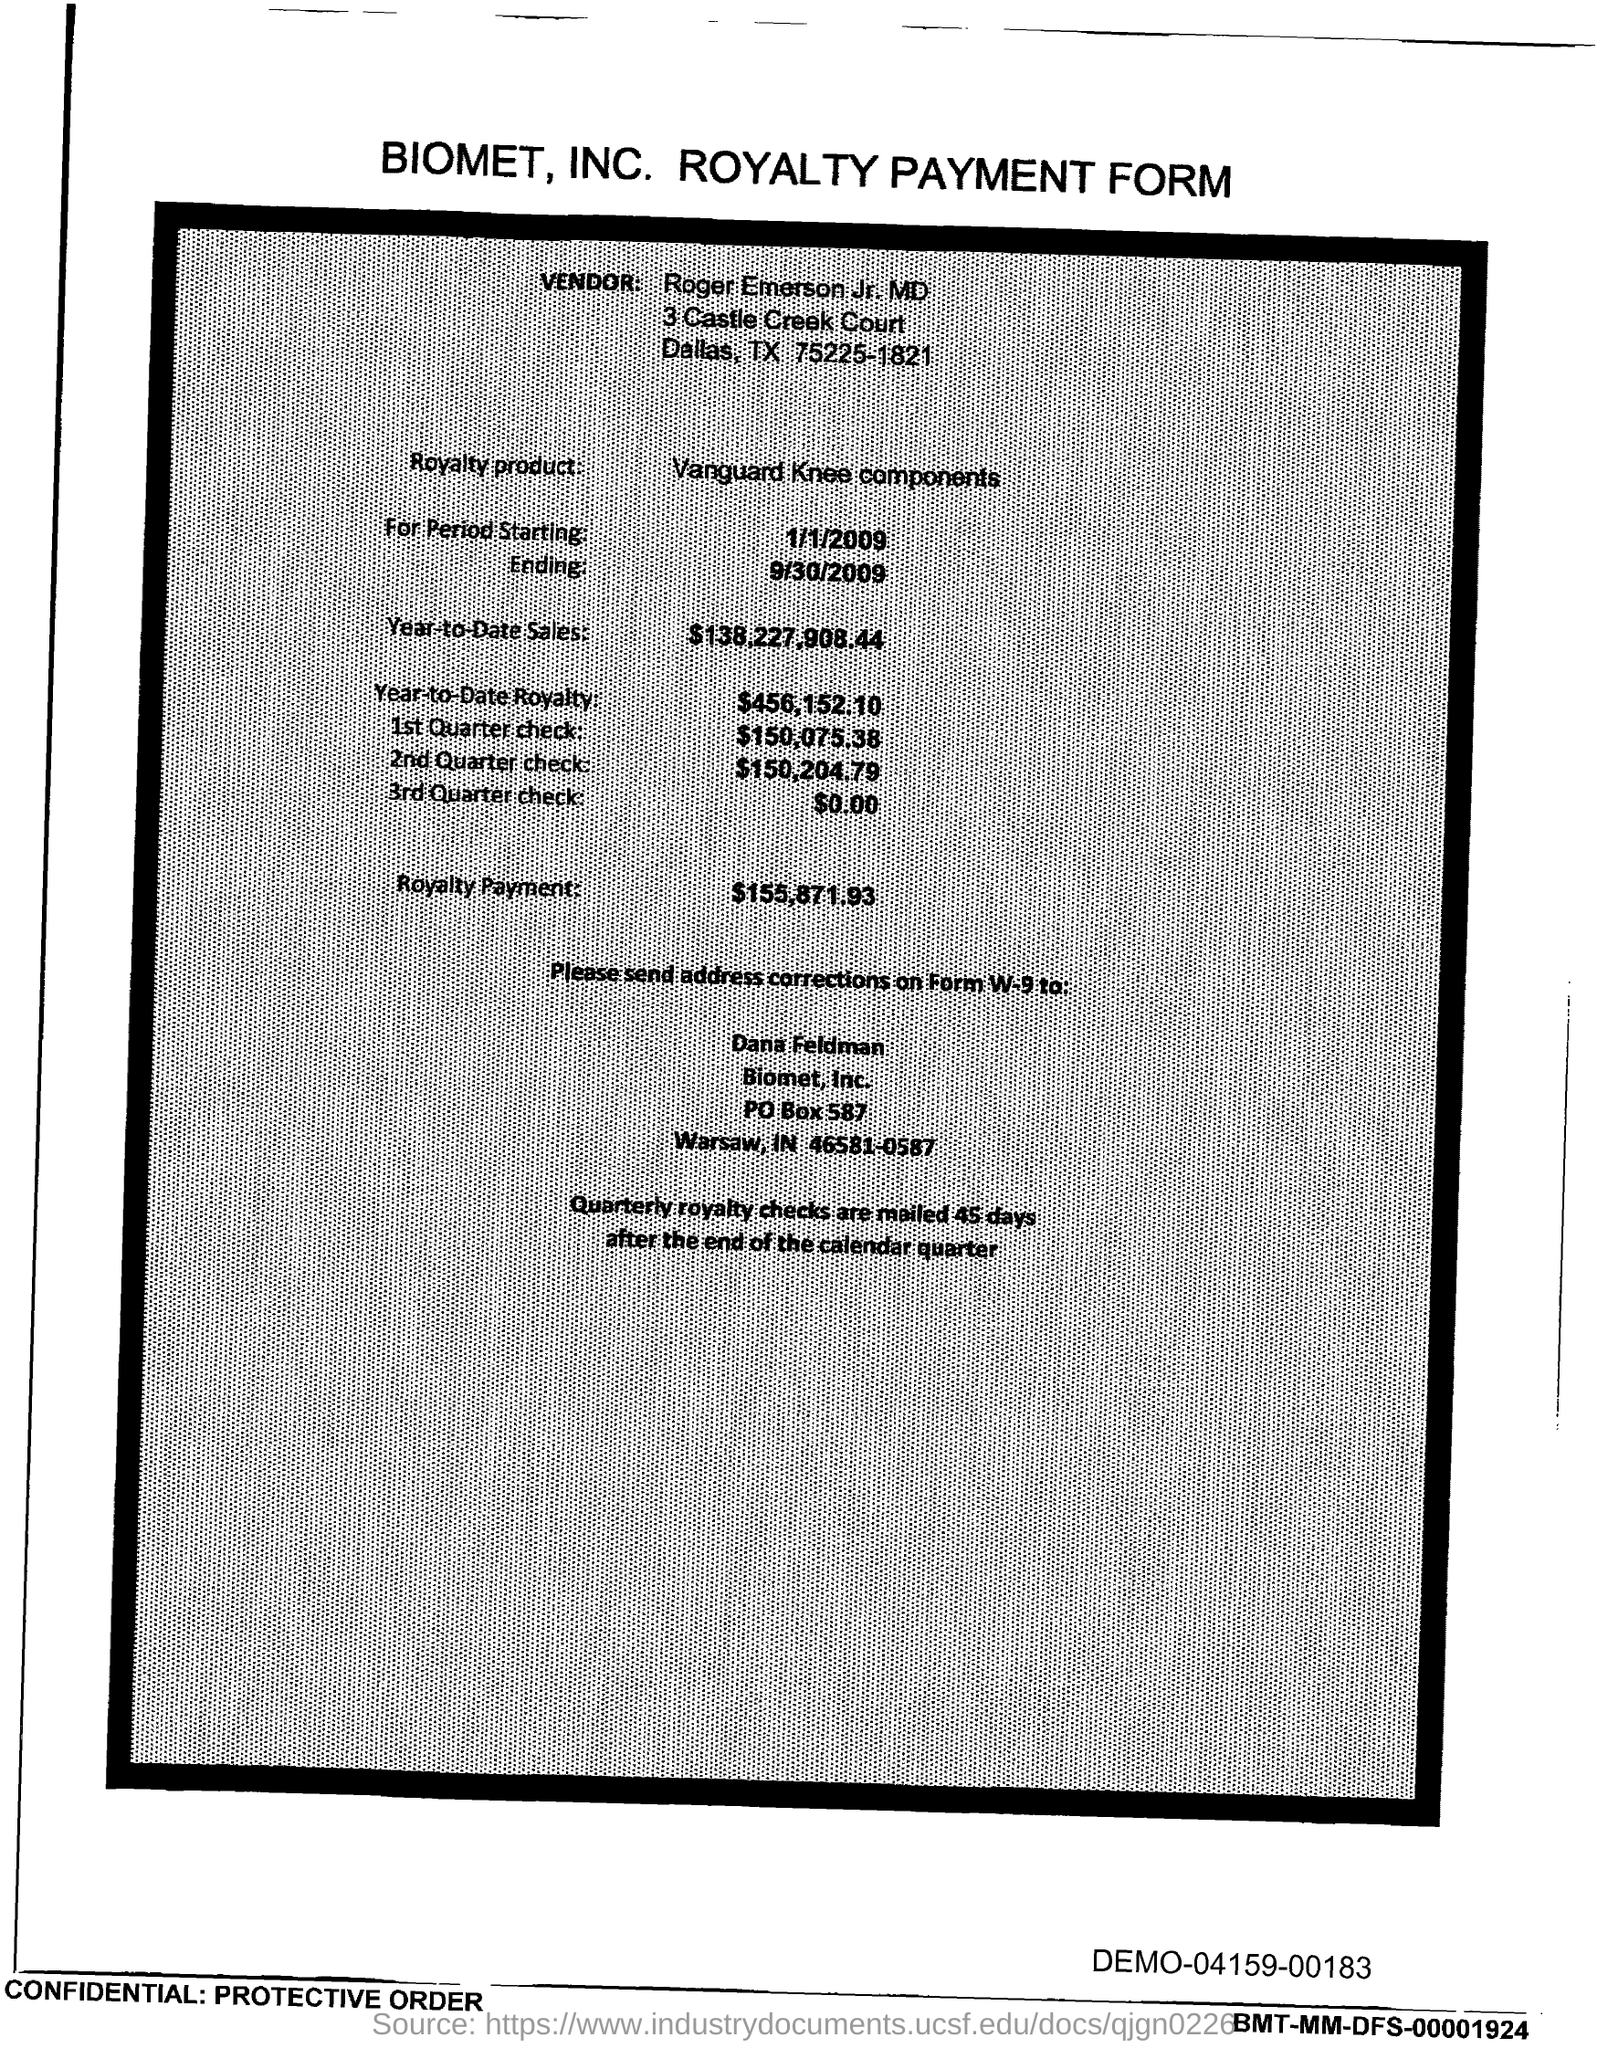Point out several critical features in this image. The PO Box number mentioned in the document is 587. 